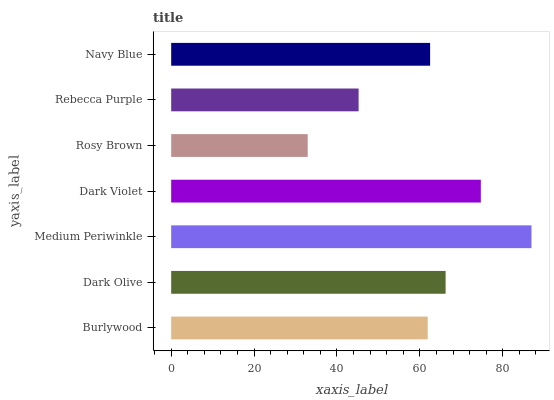Is Rosy Brown the minimum?
Answer yes or no. Yes. Is Medium Periwinkle the maximum?
Answer yes or no. Yes. Is Dark Olive the minimum?
Answer yes or no. No. Is Dark Olive the maximum?
Answer yes or no. No. Is Dark Olive greater than Burlywood?
Answer yes or no. Yes. Is Burlywood less than Dark Olive?
Answer yes or no. Yes. Is Burlywood greater than Dark Olive?
Answer yes or no. No. Is Dark Olive less than Burlywood?
Answer yes or no. No. Is Navy Blue the high median?
Answer yes or no. Yes. Is Navy Blue the low median?
Answer yes or no. Yes. Is Dark Violet the high median?
Answer yes or no. No. Is Rebecca Purple the low median?
Answer yes or no. No. 